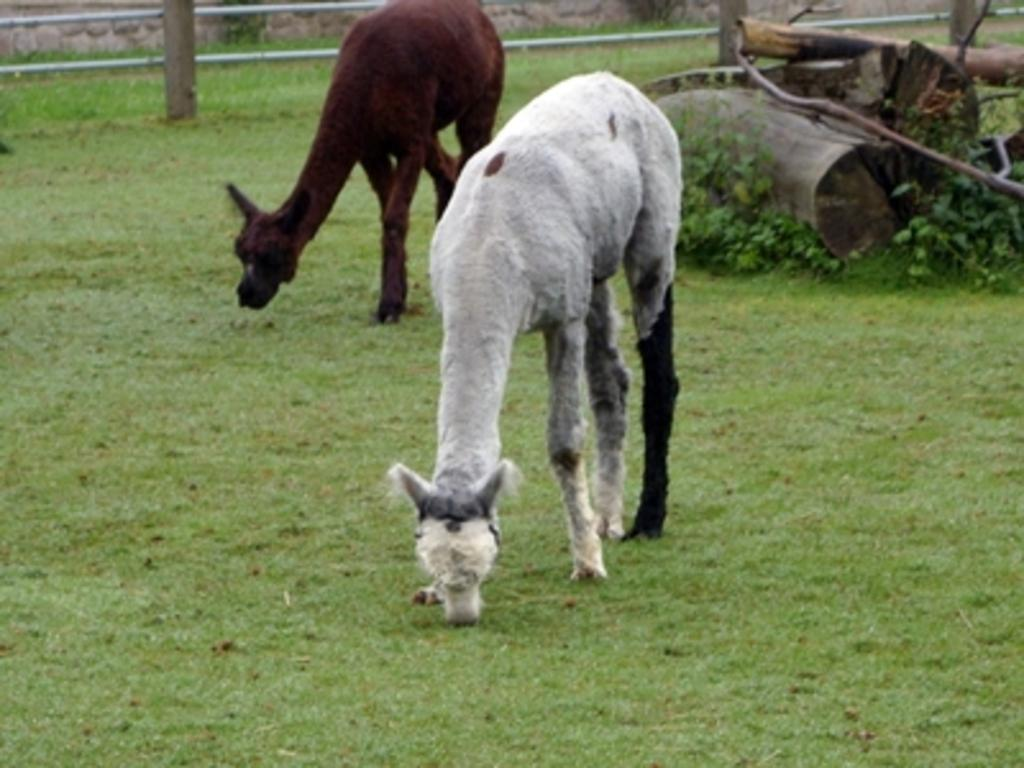How many animals are present in the image? There are two animals in the image. What is the surface the animals are standing on? The animals are standing on the ground. What type of vegetation is present on the ground? There is grass on the ground. What can be seen behind the animals? There are wooden logs behind the animals. What is visible at the top of the image? There is fencing at the top of the image. What color is the ink spilled by the person in the image? There is no person present in the image, and therefore no ink spilled. 